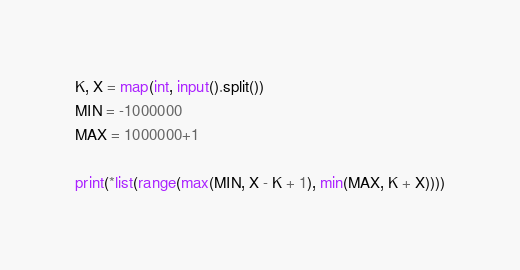<code> <loc_0><loc_0><loc_500><loc_500><_Python_>K, X = map(int, input().split())
MIN = -1000000
MAX = 1000000+1

print(*list(range(max(MIN, X - K + 1), min(MAX, K + X))))
</code> 